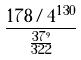<formula> <loc_0><loc_0><loc_500><loc_500>\frac { 1 7 8 / 4 ^ { 1 3 0 } } { \frac { 3 7 ^ { 9 } } { 3 2 2 } }</formula> 